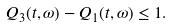Convert formula to latex. <formula><loc_0><loc_0><loc_500><loc_500>Q _ { 3 } ( t , \omega ) - Q _ { 1 } ( t , \omega ) \leq 1 .</formula> 